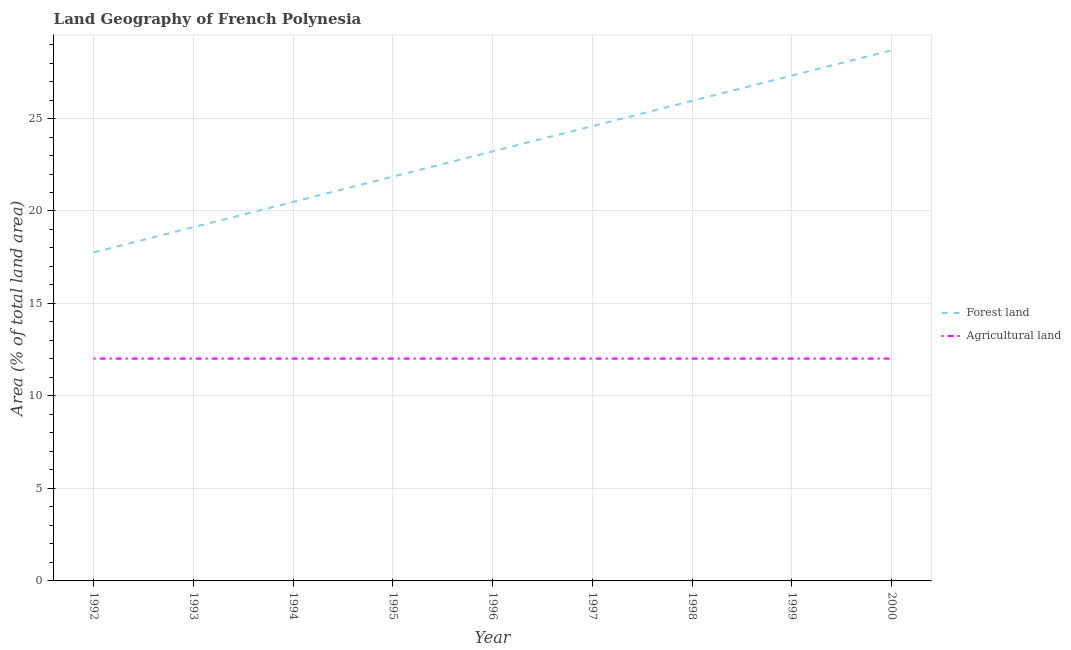How many different coloured lines are there?
Offer a terse response. 2. Does the line corresponding to percentage of land area under forests intersect with the line corresponding to percentage of land area under agriculture?
Make the answer very short. No. What is the percentage of land area under agriculture in 1994?
Offer a very short reply. 12.02. Across all years, what is the maximum percentage of land area under forests?
Offer a very short reply. 28.69. Across all years, what is the minimum percentage of land area under forests?
Your response must be concise. 17.76. In which year was the percentage of land area under agriculture minimum?
Your response must be concise. 1992. What is the total percentage of land area under forests in the graph?
Provide a succinct answer. 209.02. What is the difference between the percentage of land area under forests in 1994 and that in 1995?
Your response must be concise. -1.37. What is the difference between the percentage of land area under forests in 1994 and the percentage of land area under agriculture in 1996?
Your answer should be compact. 8.47. What is the average percentage of land area under agriculture per year?
Make the answer very short. 12.02. In the year 1995, what is the difference between the percentage of land area under agriculture and percentage of land area under forests?
Provide a succinct answer. -9.84. In how many years, is the percentage of land area under forests greater than 20 %?
Ensure brevity in your answer.  7. Is the difference between the percentage of land area under agriculture in 1992 and 1998 greater than the difference between the percentage of land area under forests in 1992 and 1998?
Your response must be concise. Yes. What is the difference between the highest and the second highest percentage of land area under agriculture?
Provide a succinct answer. 0. Is the sum of the percentage of land area under forests in 1995 and 1999 greater than the maximum percentage of land area under agriculture across all years?
Your answer should be very brief. Yes. Is the percentage of land area under agriculture strictly greater than the percentage of land area under forests over the years?
Provide a succinct answer. No. Is the percentage of land area under forests strictly less than the percentage of land area under agriculture over the years?
Your answer should be compact. No. Does the graph contain grids?
Keep it short and to the point. Yes. Where does the legend appear in the graph?
Provide a succinct answer. Center right. What is the title of the graph?
Your answer should be very brief. Land Geography of French Polynesia. What is the label or title of the X-axis?
Ensure brevity in your answer.  Year. What is the label or title of the Y-axis?
Your answer should be compact. Area (% of total land area). What is the Area (% of total land area) in Forest land in 1992?
Your answer should be very brief. 17.76. What is the Area (% of total land area) in Agricultural land in 1992?
Keep it short and to the point. 12.02. What is the Area (% of total land area) in Forest land in 1993?
Make the answer very short. 19.13. What is the Area (% of total land area) in Agricultural land in 1993?
Offer a very short reply. 12.02. What is the Area (% of total land area) of Forest land in 1994?
Provide a short and direct response. 20.49. What is the Area (% of total land area) of Agricultural land in 1994?
Your answer should be very brief. 12.02. What is the Area (% of total land area) of Forest land in 1995?
Your answer should be compact. 21.86. What is the Area (% of total land area) of Agricultural land in 1995?
Ensure brevity in your answer.  12.02. What is the Area (% of total land area) in Forest land in 1996?
Provide a short and direct response. 23.22. What is the Area (% of total land area) of Agricultural land in 1996?
Your answer should be very brief. 12.02. What is the Area (% of total land area) in Forest land in 1997?
Your answer should be very brief. 24.59. What is the Area (% of total land area) in Agricultural land in 1997?
Keep it short and to the point. 12.02. What is the Area (% of total land area) of Forest land in 1998?
Make the answer very short. 25.96. What is the Area (% of total land area) in Agricultural land in 1998?
Give a very brief answer. 12.02. What is the Area (% of total land area) of Forest land in 1999?
Provide a succinct answer. 27.32. What is the Area (% of total land area) of Agricultural land in 1999?
Your answer should be very brief. 12.02. What is the Area (% of total land area) of Forest land in 2000?
Provide a short and direct response. 28.69. What is the Area (% of total land area) of Agricultural land in 2000?
Your response must be concise. 12.02. Across all years, what is the maximum Area (% of total land area) in Forest land?
Keep it short and to the point. 28.69. Across all years, what is the maximum Area (% of total land area) in Agricultural land?
Ensure brevity in your answer.  12.02. Across all years, what is the minimum Area (% of total land area) of Forest land?
Ensure brevity in your answer.  17.76. Across all years, what is the minimum Area (% of total land area) in Agricultural land?
Ensure brevity in your answer.  12.02. What is the total Area (% of total land area) of Forest land in the graph?
Provide a short and direct response. 209.02. What is the total Area (% of total land area) of Agricultural land in the graph?
Provide a short and direct response. 108.2. What is the difference between the Area (% of total land area) of Forest land in 1992 and that in 1993?
Keep it short and to the point. -1.37. What is the difference between the Area (% of total land area) in Agricultural land in 1992 and that in 1993?
Ensure brevity in your answer.  0. What is the difference between the Area (% of total land area) in Forest land in 1992 and that in 1994?
Provide a succinct answer. -2.73. What is the difference between the Area (% of total land area) in Agricultural land in 1992 and that in 1994?
Keep it short and to the point. 0. What is the difference between the Area (% of total land area) in Forest land in 1992 and that in 1995?
Provide a succinct answer. -4.1. What is the difference between the Area (% of total land area) in Forest land in 1992 and that in 1996?
Your answer should be compact. -5.46. What is the difference between the Area (% of total land area) of Forest land in 1992 and that in 1997?
Your answer should be very brief. -6.83. What is the difference between the Area (% of total land area) in Forest land in 1992 and that in 1998?
Provide a short and direct response. -8.2. What is the difference between the Area (% of total land area) in Forest land in 1992 and that in 1999?
Give a very brief answer. -9.56. What is the difference between the Area (% of total land area) in Forest land in 1992 and that in 2000?
Provide a short and direct response. -10.93. What is the difference between the Area (% of total land area) in Agricultural land in 1992 and that in 2000?
Offer a terse response. 0. What is the difference between the Area (% of total land area) in Forest land in 1993 and that in 1994?
Your answer should be compact. -1.37. What is the difference between the Area (% of total land area) in Agricultural land in 1993 and that in 1994?
Keep it short and to the point. 0. What is the difference between the Area (% of total land area) of Forest land in 1993 and that in 1995?
Provide a short and direct response. -2.73. What is the difference between the Area (% of total land area) in Forest land in 1993 and that in 1996?
Provide a short and direct response. -4.1. What is the difference between the Area (% of total land area) in Forest land in 1993 and that in 1997?
Your answer should be compact. -5.46. What is the difference between the Area (% of total land area) in Forest land in 1993 and that in 1998?
Keep it short and to the point. -6.83. What is the difference between the Area (% of total land area) of Agricultural land in 1993 and that in 1998?
Your answer should be very brief. 0. What is the difference between the Area (% of total land area) in Forest land in 1993 and that in 1999?
Provide a short and direct response. -8.2. What is the difference between the Area (% of total land area) of Forest land in 1993 and that in 2000?
Your response must be concise. -9.56. What is the difference between the Area (% of total land area) in Agricultural land in 1993 and that in 2000?
Provide a short and direct response. 0. What is the difference between the Area (% of total land area) of Forest land in 1994 and that in 1995?
Your response must be concise. -1.37. What is the difference between the Area (% of total land area) in Agricultural land in 1994 and that in 1995?
Ensure brevity in your answer.  0. What is the difference between the Area (% of total land area) of Forest land in 1994 and that in 1996?
Provide a succinct answer. -2.73. What is the difference between the Area (% of total land area) of Forest land in 1994 and that in 1997?
Give a very brief answer. -4.1. What is the difference between the Area (% of total land area) of Forest land in 1994 and that in 1998?
Keep it short and to the point. -5.46. What is the difference between the Area (% of total land area) in Forest land in 1994 and that in 1999?
Provide a succinct answer. -6.83. What is the difference between the Area (% of total land area) in Agricultural land in 1994 and that in 1999?
Your answer should be very brief. 0. What is the difference between the Area (% of total land area) in Forest land in 1994 and that in 2000?
Offer a terse response. -8.2. What is the difference between the Area (% of total land area) of Agricultural land in 1994 and that in 2000?
Offer a very short reply. 0. What is the difference between the Area (% of total land area) of Forest land in 1995 and that in 1996?
Provide a short and direct response. -1.37. What is the difference between the Area (% of total land area) of Forest land in 1995 and that in 1997?
Provide a short and direct response. -2.73. What is the difference between the Area (% of total land area) of Forest land in 1995 and that in 1998?
Provide a succinct answer. -4.1. What is the difference between the Area (% of total land area) in Agricultural land in 1995 and that in 1998?
Your response must be concise. 0. What is the difference between the Area (% of total land area) in Forest land in 1995 and that in 1999?
Ensure brevity in your answer.  -5.46. What is the difference between the Area (% of total land area) in Forest land in 1995 and that in 2000?
Provide a succinct answer. -6.83. What is the difference between the Area (% of total land area) of Forest land in 1996 and that in 1997?
Provide a succinct answer. -1.37. What is the difference between the Area (% of total land area) in Agricultural land in 1996 and that in 1997?
Offer a terse response. 0. What is the difference between the Area (% of total land area) in Forest land in 1996 and that in 1998?
Ensure brevity in your answer.  -2.73. What is the difference between the Area (% of total land area) in Agricultural land in 1996 and that in 1998?
Offer a terse response. 0. What is the difference between the Area (% of total land area) of Forest land in 1996 and that in 1999?
Your response must be concise. -4.1. What is the difference between the Area (% of total land area) of Forest land in 1996 and that in 2000?
Offer a terse response. -5.46. What is the difference between the Area (% of total land area) in Forest land in 1997 and that in 1998?
Ensure brevity in your answer.  -1.37. What is the difference between the Area (% of total land area) of Agricultural land in 1997 and that in 1998?
Provide a short and direct response. 0. What is the difference between the Area (% of total land area) in Forest land in 1997 and that in 1999?
Your answer should be very brief. -2.73. What is the difference between the Area (% of total land area) of Agricultural land in 1997 and that in 1999?
Provide a succinct answer. 0. What is the difference between the Area (% of total land area) in Forest land in 1997 and that in 2000?
Give a very brief answer. -4.1. What is the difference between the Area (% of total land area) in Forest land in 1998 and that in 1999?
Offer a terse response. -1.37. What is the difference between the Area (% of total land area) of Agricultural land in 1998 and that in 1999?
Give a very brief answer. 0. What is the difference between the Area (% of total land area) of Forest land in 1998 and that in 2000?
Your answer should be compact. -2.73. What is the difference between the Area (% of total land area) in Agricultural land in 1998 and that in 2000?
Offer a very short reply. 0. What is the difference between the Area (% of total land area) in Forest land in 1999 and that in 2000?
Make the answer very short. -1.37. What is the difference between the Area (% of total land area) of Agricultural land in 1999 and that in 2000?
Your response must be concise. 0. What is the difference between the Area (% of total land area) in Forest land in 1992 and the Area (% of total land area) in Agricultural land in 1993?
Offer a terse response. 5.74. What is the difference between the Area (% of total land area) of Forest land in 1992 and the Area (% of total land area) of Agricultural land in 1994?
Provide a succinct answer. 5.74. What is the difference between the Area (% of total land area) of Forest land in 1992 and the Area (% of total land area) of Agricultural land in 1995?
Your response must be concise. 5.74. What is the difference between the Area (% of total land area) in Forest land in 1992 and the Area (% of total land area) in Agricultural land in 1996?
Keep it short and to the point. 5.74. What is the difference between the Area (% of total land area) of Forest land in 1992 and the Area (% of total land area) of Agricultural land in 1997?
Offer a very short reply. 5.74. What is the difference between the Area (% of total land area) in Forest land in 1992 and the Area (% of total land area) in Agricultural land in 1998?
Offer a very short reply. 5.74. What is the difference between the Area (% of total land area) in Forest land in 1992 and the Area (% of total land area) in Agricultural land in 1999?
Your answer should be compact. 5.74. What is the difference between the Area (% of total land area) of Forest land in 1992 and the Area (% of total land area) of Agricultural land in 2000?
Make the answer very short. 5.74. What is the difference between the Area (% of total land area) of Forest land in 1993 and the Area (% of total land area) of Agricultural land in 1994?
Ensure brevity in your answer.  7.1. What is the difference between the Area (% of total land area) in Forest land in 1993 and the Area (% of total land area) in Agricultural land in 1995?
Provide a short and direct response. 7.1. What is the difference between the Area (% of total land area) in Forest land in 1993 and the Area (% of total land area) in Agricultural land in 1996?
Make the answer very short. 7.1. What is the difference between the Area (% of total land area) in Forest land in 1993 and the Area (% of total land area) in Agricultural land in 1997?
Offer a terse response. 7.1. What is the difference between the Area (% of total land area) of Forest land in 1993 and the Area (% of total land area) of Agricultural land in 1998?
Keep it short and to the point. 7.1. What is the difference between the Area (% of total land area) in Forest land in 1993 and the Area (% of total land area) in Agricultural land in 1999?
Your answer should be compact. 7.1. What is the difference between the Area (% of total land area) of Forest land in 1993 and the Area (% of total land area) of Agricultural land in 2000?
Your answer should be very brief. 7.1. What is the difference between the Area (% of total land area) in Forest land in 1994 and the Area (% of total land area) in Agricultural land in 1995?
Offer a terse response. 8.47. What is the difference between the Area (% of total land area) of Forest land in 1994 and the Area (% of total land area) of Agricultural land in 1996?
Your answer should be very brief. 8.47. What is the difference between the Area (% of total land area) of Forest land in 1994 and the Area (% of total land area) of Agricultural land in 1997?
Make the answer very short. 8.47. What is the difference between the Area (% of total land area) in Forest land in 1994 and the Area (% of total land area) in Agricultural land in 1998?
Offer a very short reply. 8.47. What is the difference between the Area (% of total land area) of Forest land in 1994 and the Area (% of total land area) of Agricultural land in 1999?
Provide a succinct answer. 8.47. What is the difference between the Area (% of total land area) in Forest land in 1994 and the Area (% of total land area) in Agricultural land in 2000?
Keep it short and to the point. 8.47. What is the difference between the Area (% of total land area) in Forest land in 1995 and the Area (% of total land area) in Agricultural land in 1996?
Keep it short and to the point. 9.84. What is the difference between the Area (% of total land area) of Forest land in 1995 and the Area (% of total land area) of Agricultural land in 1997?
Make the answer very short. 9.84. What is the difference between the Area (% of total land area) of Forest land in 1995 and the Area (% of total land area) of Agricultural land in 1998?
Offer a very short reply. 9.84. What is the difference between the Area (% of total land area) in Forest land in 1995 and the Area (% of total land area) in Agricultural land in 1999?
Offer a very short reply. 9.84. What is the difference between the Area (% of total land area) in Forest land in 1995 and the Area (% of total land area) in Agricultural land in 2000?
Offer a very short reply. 9.84. What is the difference between the Area (% of total land area) in Forest land in 1996 and the Area (% of total land area) in Agricultural land in 1997?
Provide a succinct answer. 11.2. What is the difference between the Area (% of total land area) of Forest land in 1996 and the Area (% of total land area) of Agricultural land in 1998?
Provide a short and direct response. 11.2. What is the difference between the Area (% of total land area) in Forest land in 1996 and the Area (% of total land area) in Agricultural land in 1999?
Your response must be concise. 11.2. What is the difference between the Area (% of total land area) of Forest land in 1996 and the Area (% of total land area) of Agricultural land in 2000?
Provide a succinct answer. 11.2. What is the difference between the Area (% of total land area) in Forest land in 1997 and the Area (% of total land area) in Agricultural land in 1998?
Your answer should be very brief. 12.57. What is the difference between the Area (% of total land area) of Forest land in 1997 and the Area (% of total land area) of Agricultural land in 1999?
Your answer should be very brief. 12.57. What is the difference between the Area (% of total land area) of Forest land in 1997 and the Area (% of total land area) of Agricultural land in 2000?
Ensure brevity in your answer.  12.57. What is the difference between the Area (% of total land area) in Forest land in 1998 and the Area (% of total land area) in Agricultural land in 1999?
Provide a succinct answer. 13.93. What is the difference between the Area (% of total land area) in Forest land in 1998 and the Area (% of total land area) in Agricultural land in 2000?
Give a very brief answer. 13.93. What is the difference between the Area (% of total land area) of Forest land in 1999 and the Area (% of total land area) of Agricultural land in 2000?
Your answer should be very brief. 15.3. What is the average Area (% of total land area) in Forest land per year?
Provide a succinct answer. 23.22. What is the average Area (% of total land area) of Agricultural land per year?
Provide a succinct answer. 12.02. In the year 1992, what is the difference between the Area (% of total land area) in Forest land and Area (% of total land area) in Agricultural land?
Ensure brevity in your answer.  5.74. In the year 1993, what is the difference between the Area (% of total land area) of Forest land and Area (% of total land area) of Agricultural land?
Your response must be concise. 7.1. In the year 1994, what is the difference between the Area (% of total land area) of Forest land and Area (% of total land area) of Agricultural land?
Offer a very short reply. 8.47. In the year 1995, what is the difference between the Area (% of total land area) of Forest land and Area (% of total land area) of Agricultural land?
Make the answer very short. 9.84. In the year 1996, what is the difference between the Area (% of total land area) in Forest land and Area (% of total land area) in Agricultural land?
Your response must be concise. 11.2. In the year 1997, what is the difference between the Area (% of total land area) in Forest land and Area (% of total land area) in Agricultural land?
Give a very brief answer. 12.57. In the year 1998, what is the difference between the Area (% of total land area) of Forest land and Area (% of total land area) of Agricultural land?
Provide a succinct answer. 13.93. In the year 1999, what is the difference between the Area (% of total land area) of Forest land and Area (% of total land area) of Agricultural land?
Your answer should be very brief. 15.3. In the year 2000, what is the difference between the Area (% of total land area) in Forest land and Area (% of total land area) in Agricultural land?
Give a very brief answer. 16.67. What is the ratio of the Area (% of total land area) of Agricultural land in 1992 to that in 1993?
Ensure brevity in your answer.  1. What is the ratio of the Area (% of total land area) of Forest land in 1992 to that in 1994?
Provide a short and direct response. 0.87. What is the ratio of the Area (% of total land area) in Forest land in 1992 to that in 1995?
Your answer should be very brief. 0.81. What is the ratio of the Area (% of total land area) in Agricultural land in 1992 to that in 1995?
Offer a terse response. 1. What is the ratio of the Area (% of total land area) in Forest land in 1992 to that in 1996?
Make the answer very short. 0.76. What is the ratio of the Area (% of total land area) of Forest land in 1992 to that in 1997?
Your answer should be very brief. 0.72. What is the ratio of the Area (% of total land area) of Forest land in 1992 to that in 1998?
Offer a terse response. 0.68. What is the ratio of the Area (% of total land area) in Agricultural land in 1992 to that in 1998?
Your response must be concise. 1. What is the ratio of the Area (% of total land area) of Forest land in 1992 to that in 1999?
Your answer should be compact. 0.65. What is the ratio of the Area (% of total land area) of Agricultural land in 1992 to that in 1999?
Make the answer very short. 1. What is the ratio of the Area (% of total land area) of Forest land in 1992 to that in 2000?
Your answer should be compact. 0.62. What is the ratio of the Area (% of total land area) in Agricultural land in 1993 to that in 1995?
Your answer should be compact. 1. What is the ratio of the Area (% of total land area) in Forest land in 1993 to that in 1996?
Offer a very short reply. 0.82. What is the ratio of the Area (% of total land area) in Forest land in 1993 to that in 1997?
Make the answer very short. 0.78. What is the ratio of the Area (% of total land area) of Agricultural land in 1993 to that in 1997?
Provide a succinct answer. 1. What is the ratio of the Area (% of total land area) of Forest land in 1993 to that in 1998?
Ensure brevity in your answer.  0.74. What is the ratio of the Area (% of total land area) in Forest land in 1993 to that in 1999?
Your response must be concise. 0.7. What is the ratio of the Area (% of total land area) of Agricultural land in 1993 to that in 1999?
Your answer should be very brief. 1. What is the ratio of the Area (% of total land area) of Forest land in 1994 to that in 1996?
Make the answer very short. 0.88. What is the ratio of the Area (% of total land area) of Agricultural land in 1994 to that in 1996?
Your response must be concise. 1. What is the ratio of the Area (% of total land area) of Forest land in 1994 to that in 1997?
Your answer should be compact. 0.83. What is the ratio of the Area (% of total land area) in Forest land in 1994 to that in 1998?
Make the answer very short. 0.79. What is the ratio of the Area (% of total land area) in Agricultural land in 1994 to that in 1998?
Ensure brevity in your answer.  1. What is the ratio of the Area (% of total land area) in Agricultural land in 1994 to that in 1999?
Provide a succinct answer. 1. What is the ratio of the Area (% of total land area) of Forest land in 1994 to that in 2000?
Provide a short and direct response. 0.71. What is the ratio of the Area (% of total land area) in Forest land in 1995 to that in 1997?
Offer a very short reply. 0.89. What is the ratio of the Area (% of total land area) in Agricultural land in 1995 to that in 1997?
Keep it short and to the point. 1. What is the ratio of the Area (% of total land area) of Forest land in 1995 to that in 1998?
Give a very brief answer. 0.84. What is the ratio of the Area (% of total land area) of Agricultural land in 1995 to that in 1998?
Make the answer very short. 1. What is the ratio of the Area (% of total land area) of Forest land in 1995 to that in 2000?
Offer a very short reply. 0.76. What is the ratio of the Area (% of total land area) of Agricultural land in 1995 to that in 2000?
Offer a very short reply. 1. What is the ratio of the Area (% of total land area) in Forest land in 1996 to that in 1997?
Offer a terse response. 0.94. What is the ratio of the Area (% of total land area) in Forest land in 1996 to that in 1998?
Provide a succinct answer. 0.89. What is the ratio of the Area (% of total land area) in Agricultural land in 1996 to that in 1998?
Make the answer very short. 1. What is the ratio of the Area (% of total land area) of Forest land in 1996 to that in 2000?
Your answer should be very brief. 0.81. What is the ratio of the Area (% of total land area) in Forest land in 1997 to that in 1998?
Provide a succinct answer. 0.95. What is the ratio of the Area (% of total land area) in Agricultural land in 1997 to that in 1998?
Offer a very short reply. 1. What is the ratio of the Area (% of total land area) of Forest land in 1997 to that in 1999?
Make the answer very short. 0.9. What is the ratio of the Area (% of total land area) in Agricultural land in 1997 to that in 1999?
Make the answer very short. 1. What is the ratio of the Area (% of total land area) of Forest land in 1998 to that in 1999?
Your response must be concise. 0.95. What is the ratio of the Area (% of total land area) of Forest land in 1998 to that in 2000?
Make the answer very short. 0.9. What is the difference between the highest and the second highest Area (% of total land area) of Forest land?
Ensure brevity in your answer.  1.37. What is the difference between the highest and the lowest Area (% of total land area) of Forest land?
Provide a succinct answer. 10.93. 